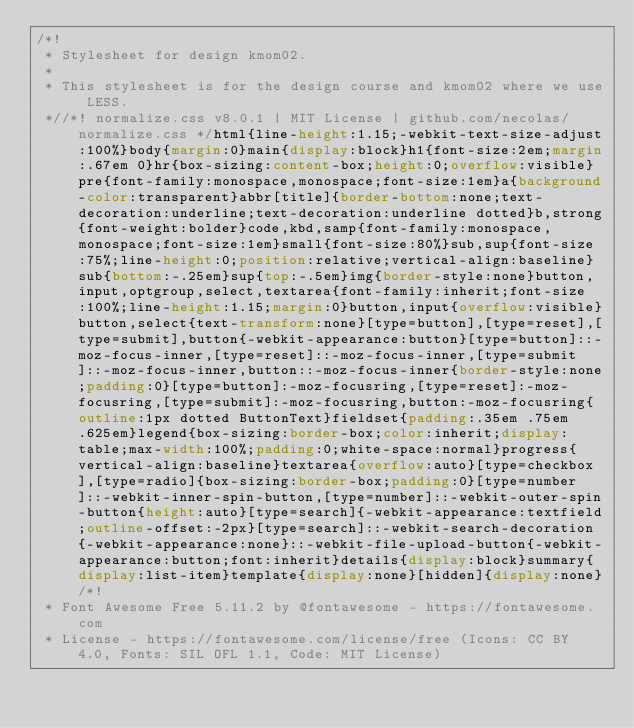<code> <loc_0><loc_0><loc_500><loc_500><_CSS_>/*!
 * Stylesheet for design kmom02.
 *
 * This stylesheet is for the design course and kmom02 where we use LESS.
 *//*! normalize.css v8.0.1 | MIT License | github.com/necolas/normalize.css */html{line-height:1.15;-webkit-text-size-adjust:100%}body{margin:0}main{display:block}h1{font-size:2em;margin:.67em 0}hr{box-sizing:content-box;height:0;overflow:visible}pre{font-family:monospace,monospace;font-size:1em}a{background-color:transparent}abbr[title]{border-bottom:none;text-decoration:underline;text-decoration:underline dotted}b,strong{font-weight:bolder}code,kbd,samp{font-family:monospace,monospace;font-size:1em}small{font-size:80%}sub,sup{font-size:75%;line-height:0;position:relative;vertical-align:baseline}sub{bottom:-.25em}sup{top:-.5em}img{border-style:none}button,input,optgroup,select,textarea{font-family:inherit;font-size:100%;line-height:1.15;margin:0}button,input{overflow:visible}button,select{text-transform:none}[type=button],[type=reset],[type=submit],button{-webkit-appearance:button}[type=button]::-moz-focus-inner,[type=reset]::-moz-focus-inner,[type=submit]::-moz-focus-inner,button::-moz-focus-inner{border-style:none;padding:0}[type=button]:-moz-focusring,[type=reset]:-moz-focusring,[type=submit]:-moz-focusring,button:-moz-focusring{outline:1px dotted ButtonText}fieldset{padding:.35em .75em .625em}legend{box-sizing:border-box;color:inherit;display:table;max-width:100%;padding:0;white-space:normal}progress{vertical-align:baseline}textarea{overflow:auto}[type=checkbox],[type=radio]{box-sizing:border-box;padding:0}[type=number]::-webkit-inner-spin-button,[type=number]::-webkit-outer-spin-button{height:auto}[type=search]{-webkit-appearance:textfield;outline-offset:-2px}[type=search]::-webkit-search-decoration{-webkit-appearance:none}::-webkit-file-upload-button{-webkit-appearance:button;font:inherit}details{display:block}summary{display:list-item}template{display:none}[hidden]{display:none}/*!
 * Font Awesome Free 5.11.2 by @fontawesome - https://fontawesome.com
 * License - https://fontawesome.com/license/free (Icons: CC BY 4.0, Fonts: SIL OFL 1.1, Code: MIT License)</code> 